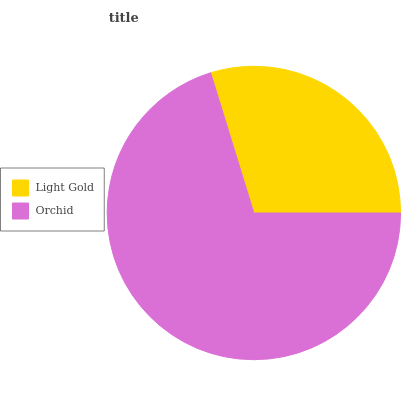Is Light Gold the minimum?
Answer yes or no. Yes. Is Orchid the maximum?
Answer yes or no. Yes. Is Orchid the minimum?
Answer yes or no. No. Is Orchid greater than Light Gold?
Answer yes or no. Yes. Is Light Gold less than Orchid?
Answer yes or no. Yes. Is Light Gold greater than Orchid?
Answer yes or no. No. Is Orchid less than Light Gold?
Answer yes or no. No. Is Orchid the high median?
Answer yes or no. Yes. Is Light Gold the low median?
Answer yes or no. Yes. Is Light Gold the high median?
Answer yes or no. No. Is Orchid the low median?
Answer yes or no. No. 